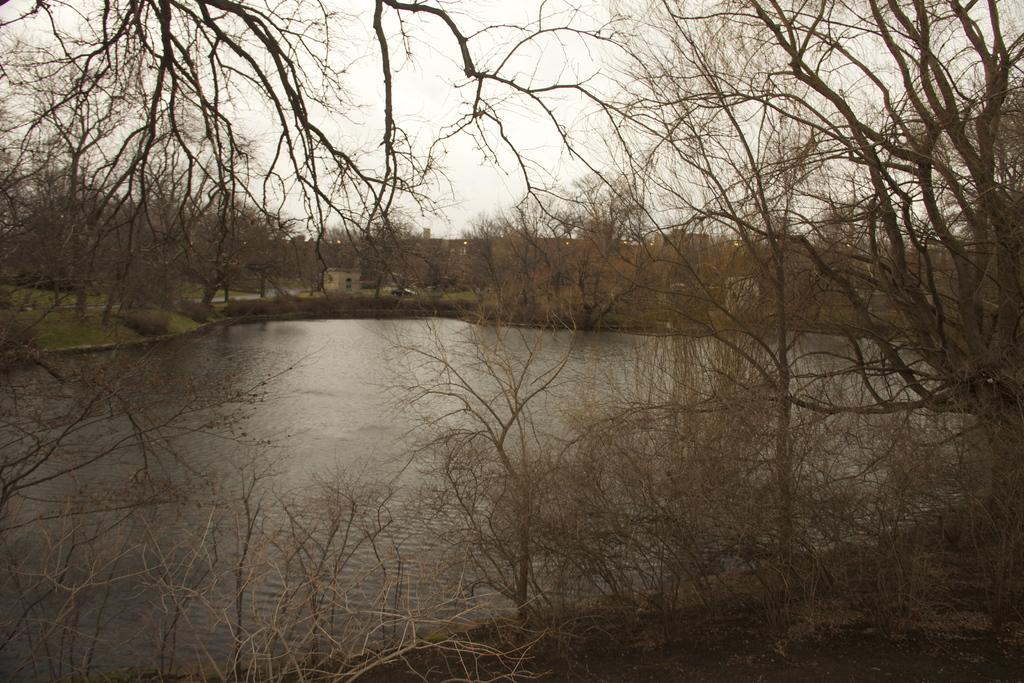What is the main feature in the middle of the image? There is a lake at the center of the image. What type of vegetation surrounds the lake? There are trees surrounding the lake. What can be seen in the background of the image? There is a building and the sky visible in the background of the image. How many bikes are parked near the sugar cane field in the image? There is no mention of bikes or sugar cane fields in the image; it features a lake surrounded by trees, with a building and the sky visible in the background. 